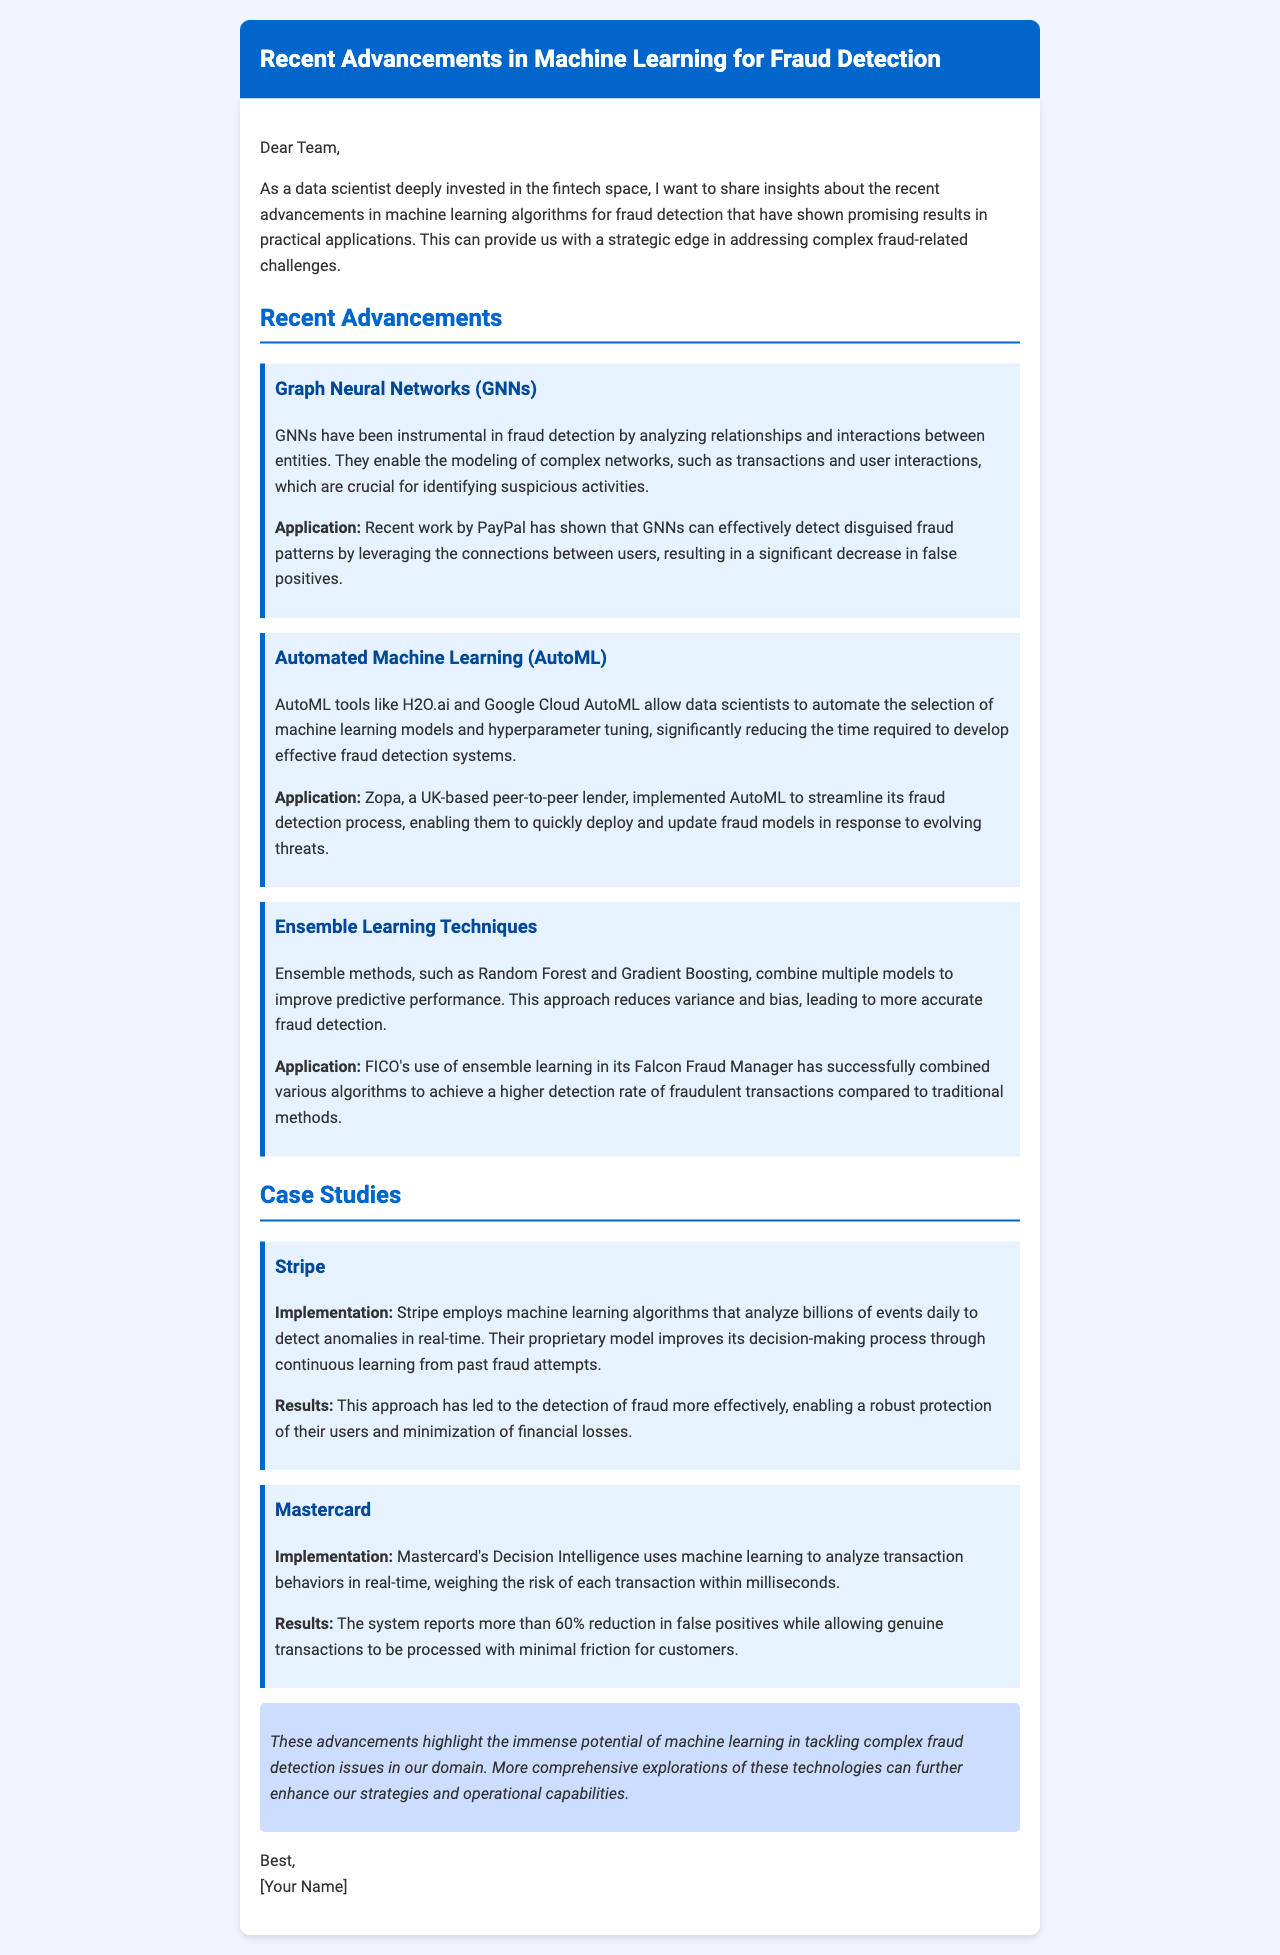What is the main focus of the document? The document discusses recent advancements in machine learning algorithms specifically for fraud detection in the fintech space.
Answer: fraud detection Which company implemented GNNs for fraud detection? The document states that PayPal has utilized Graph Neural Networks to effectively detect disguised fraud patterns.
Answer: PayPal What technique does Zopa use in its fraud detection process? According to the document, Zopa implemented Automated Machine Learning (AutoML) to streamline its fraud detection system.
Answer: AutoML What percentage reduction in false positives did Mastercard achieve? The document mentions that Mastercard reported more than a 60% reduction in false positives with their system.
Answer: 60% What is the primary benefit of ensemble learning as mentioned? The document articulates that ensemble methods combine multiple models to improve predictive performance, reducing variance and bias in fraud detection.
Answer: predictive performance What kind of learning does Stripe's model employ? The document indicates that Stripe employs continuous learning from past fraud attempts to improve its detection process.
Answer: continuous learning What does the conclusion emphasize about machine learning? The conclusion of the document highlights the immense potential of machine learning in addressing complex fraud detection issues.
Answer: immense potential What is the primary application of H2O.ai mentioned? The document states that H2O.ai is used for automating the selection of machine learning models and hyperparameter tuning.
Answer: automating selection 